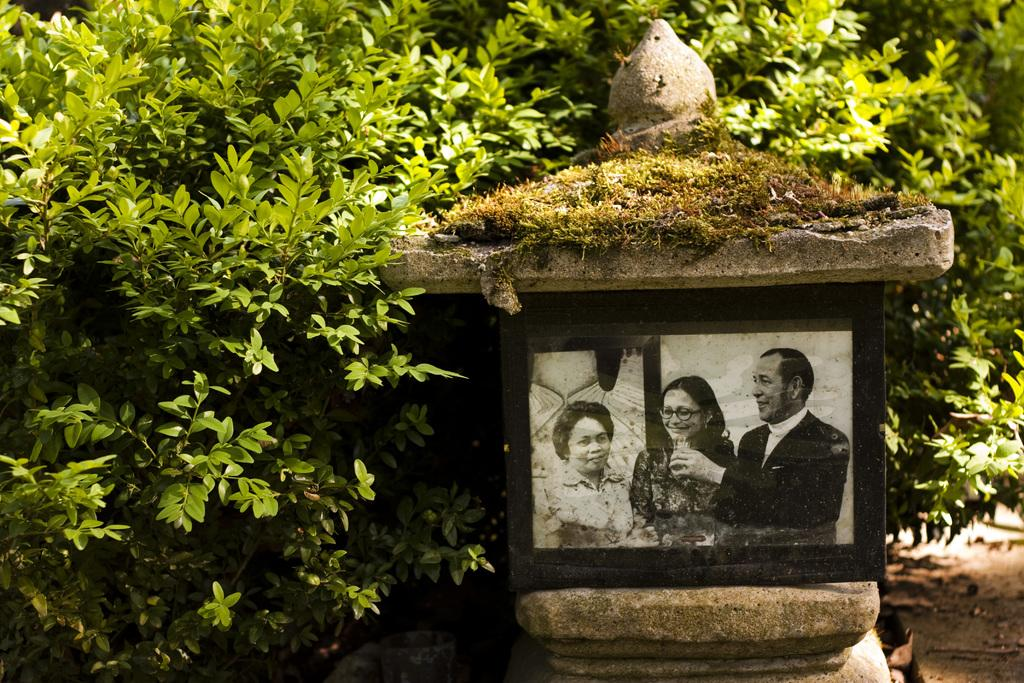What is the main subject of the image? There is a frame in the image. How many people are in the frame? There are three persons in the frame. What can be seen in the background of the image? There are plants in the background of the image. What is the color of the plants? The plants are green in color. What type of tax is being discussed by the three persons in the image? There is no indication in the image that the three persons are discussing any type of tax. 